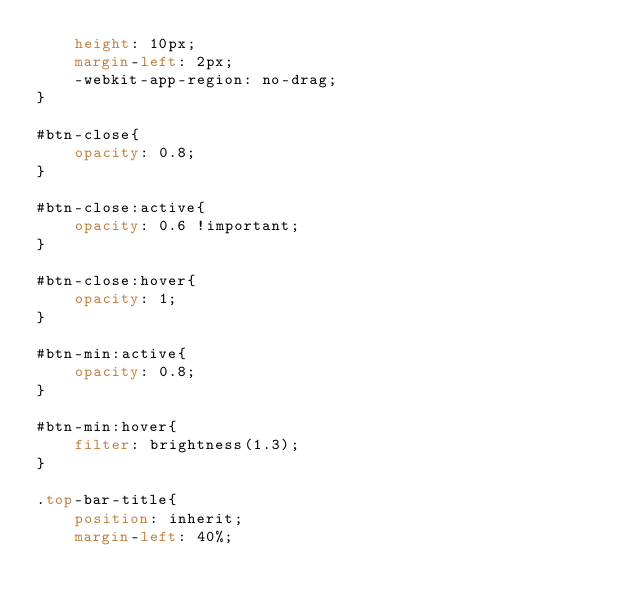Convert code to text. <code><loc_0><loc_0><loc_500><loc_500><_CSS_>    height: 10px;
    margin-left: 2px;
    -webkit-app-region: no-drag;
}

#btn-close{
    opacity: 0.8;
}

#btn-close:active{
    opacity: 0.6 !important;
}

#btn-close:hover{
    opacity: 1;
}

#btn-min:active{
    opacity: 0.8;
}

#btn-min:hover{
    filter: brightness(1.3);
}

.top-bar-title{
    position: inherit;
    margin-left: 40%;</code> 